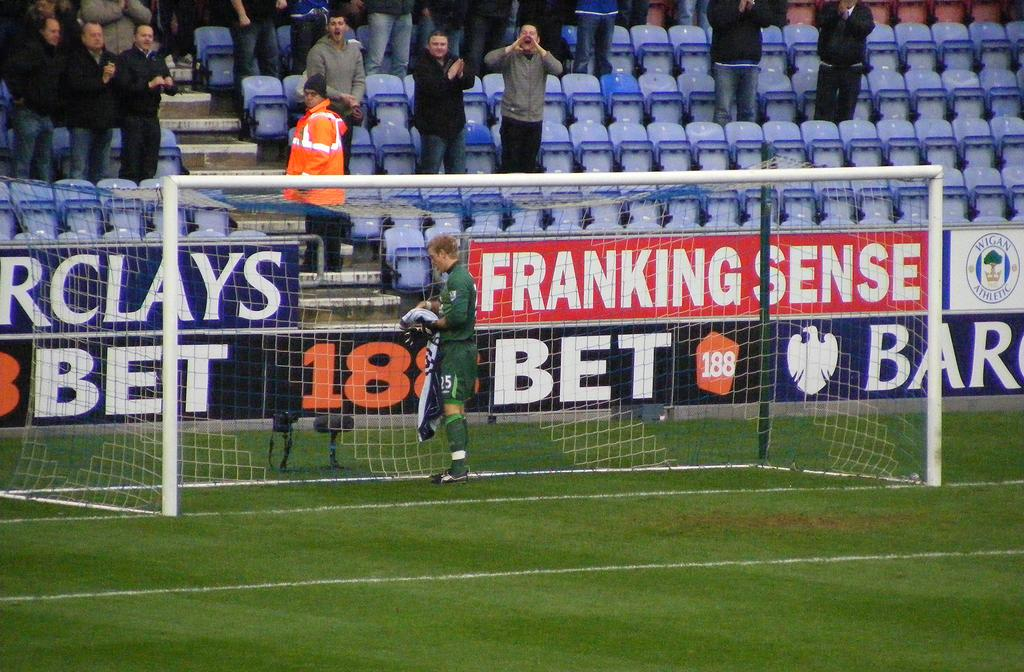What type of vegetation can be seen in the image? There is grass in the image. Who or what is present in the image? There are people in the image. What type of furniture is visible in the image? There are chairs in the image. What architectural feature is present in the image? There are steps in the image. What type of advertising is present in the image? There are hoardings in the image. What type of material is present in the image? There is mesh in the image. What type of structural element is present in the image? There are rods in the image. What else can be seen in the image besides the mentioned elements? There are objects in the image. Can you tell me how many volleyballs are being played with in the image? There is no volleyball present in the image. What type of care is being provided to the people in the image? The image does not show any care being provided to the people; it only shows their presence. What credit card is being used by the people in the image? There is no credit card usage depicted in the image. 